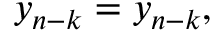Convert formula to latex. <formula><loc_0><loc_0><loc_500><loc_500>y _ { n - k } = y _ { n - k } ,</formula> 